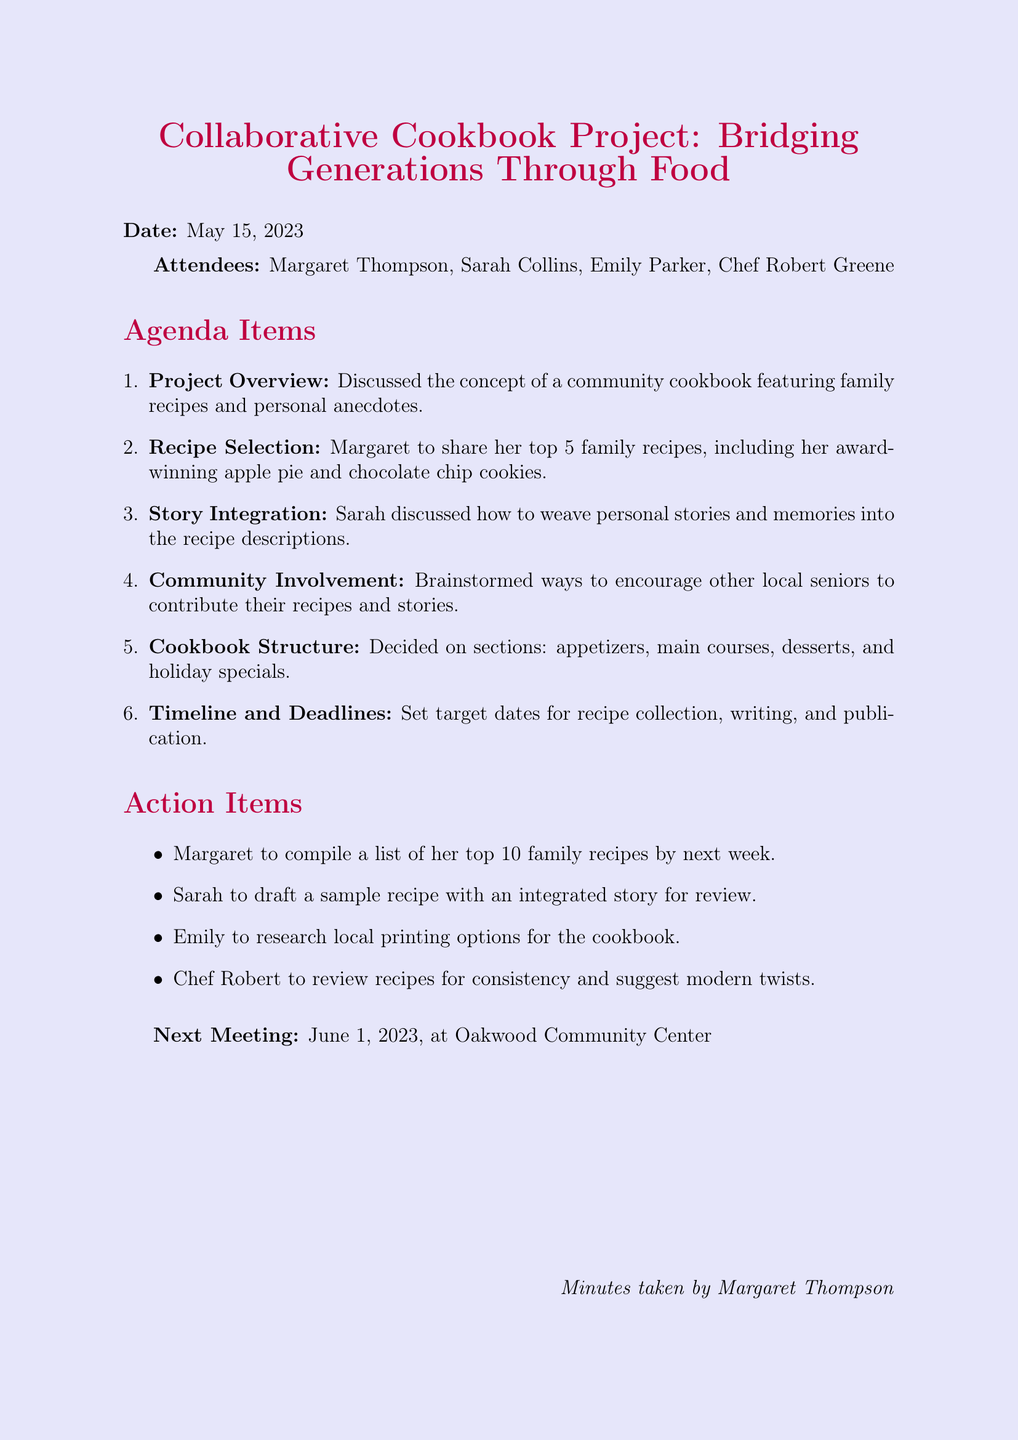What is the meeting title? The meeting title is the heading of the document, summarizing the purpose of the meeting.
Answer: Collaborative Cookbook Project: Bridging Generations Through Food What is the date of the meeting? The date of the meeting is clearly stated in the document near the title, providing the schedule of the gathering.
Answer: May 15, 2023 Who attended the meeting? The attendees are listed in the document, detailing who participated in the brainstorming session.
Answer: Margaret Thompson, Sarah Collins, Emily Parker, Chef Robert Greene What is one of Margaret's top family recipes? The document mentions Margaret's top family recipes, which includes specific dishes she intends to share.
Answer: award-winning apple pie What is Sarah's role in the project? Sarah's role in the project involves a specific task related to the integration of personal stories into the cookbook.
Answer: discuss how to weave personal stories How many sections are there planned for the cookbook? The document outlines different sections to be included in the cookbook, indicating the structure being considered.
Answer: four When is the next meeting scheduled? The date and location of the next meeting are included, providing information about future planning sessions.
Answer: June 1, 2023, at Oakwood Community Center What action is Emily responsible for? The action items detail specific tasks assigned to each attendee, including Emily's responsibilities.
Answer: research local printing options What kinds of recipes will be featured in the cookbook? The types of recipes mentioned indicate the theme and scope of the cookbook project as discussed in the meeting.
Answer: family recipes and personal anecdotes 